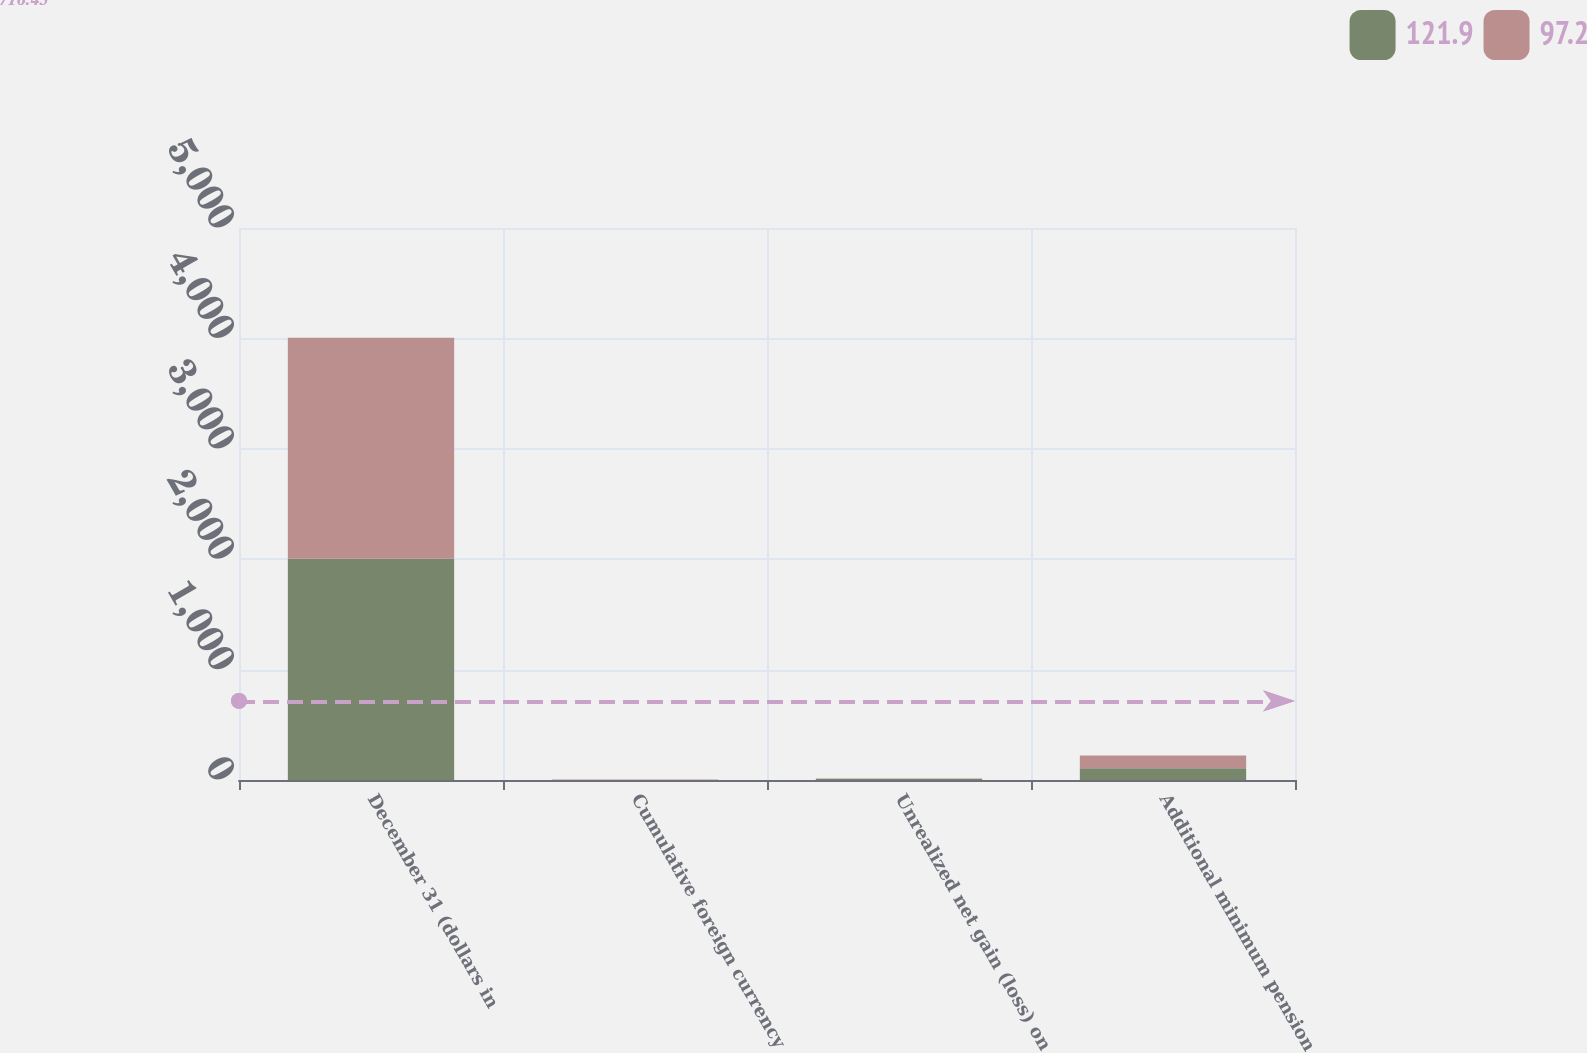Convert chart. <chart><loc_0><loc_0><loc_500><loc_500><stacked_bar_chart><ecel><fcel>December 31 (dollars in<fcel>Cumulative foreign currency<fcel>Unrealized net gain (loss) on<fcel>Additional minimum pension<nl><fcel>121.9<fcel>2003<fcel>0.8<fcel>9.3<fcel>107.3<nl><fcel>97.2<fcel>2002<fcel>3.4<fcel>3.8<fcel>114.7<nl></chart> 